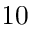Convert formula to latex. <formula><loc_0><loc_0><loc_500><loc_500>1 0</formula> 